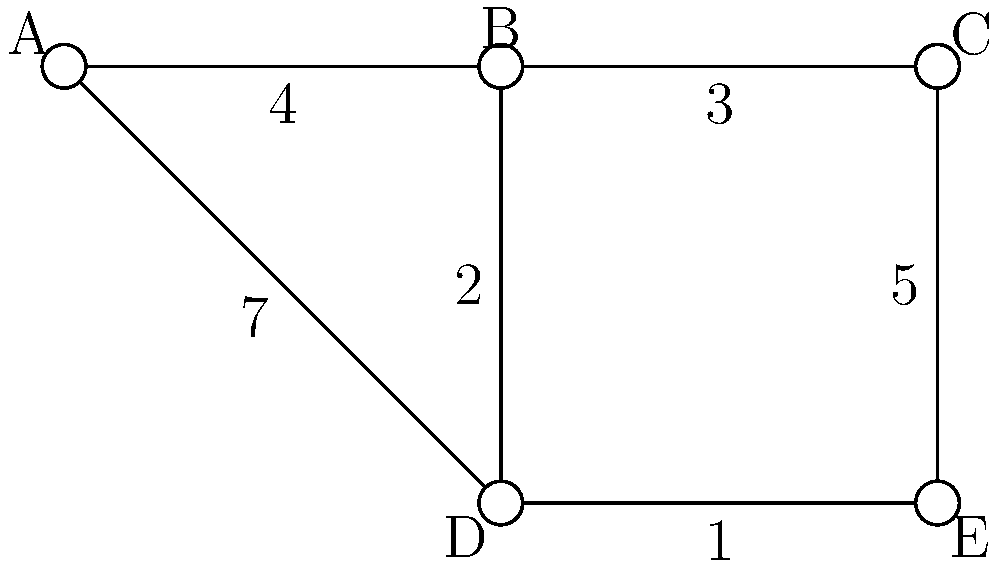In the given weighted graph, inspired by Dr. Basit Bilal Koshal's research on network optimization, find the shortest path from vertex A to vertex E. What is the total weight of this path? To find the shortest path from A to E, we'll use Dijkstra's algorithm, a method often discussed in Dr. Koshal's advanced graph theory lectures:

1) Initialize:
   - Distance to A = 0
   - Distance to all other vertices = infinity
   - Set of unvisited nodes = {A, B, C, D, E}

2) From A:
   - A to B: 4
   - A to D: 7
   - Update distances: A(0), B(4), C(∞), D(7), E(∞)

3) Visit B (closest unvisited):
   - B to C: 4 + 3 = 7
   - B to D: 4 + 2 = 6 (shorter than current D, update)
   - Update distances: A(0), B(4), C(7), D(6), E(∞)

4) Visit D (closest unvisited):
   - D to E: 6 + 1 = 7
   - Update distances: A(0), B(4), C(7), D(6), E(7)

5) Visit C and E (no further updates possible)

The shortest path is A → B → D → E with a total weight of 7.
Answer: 7 